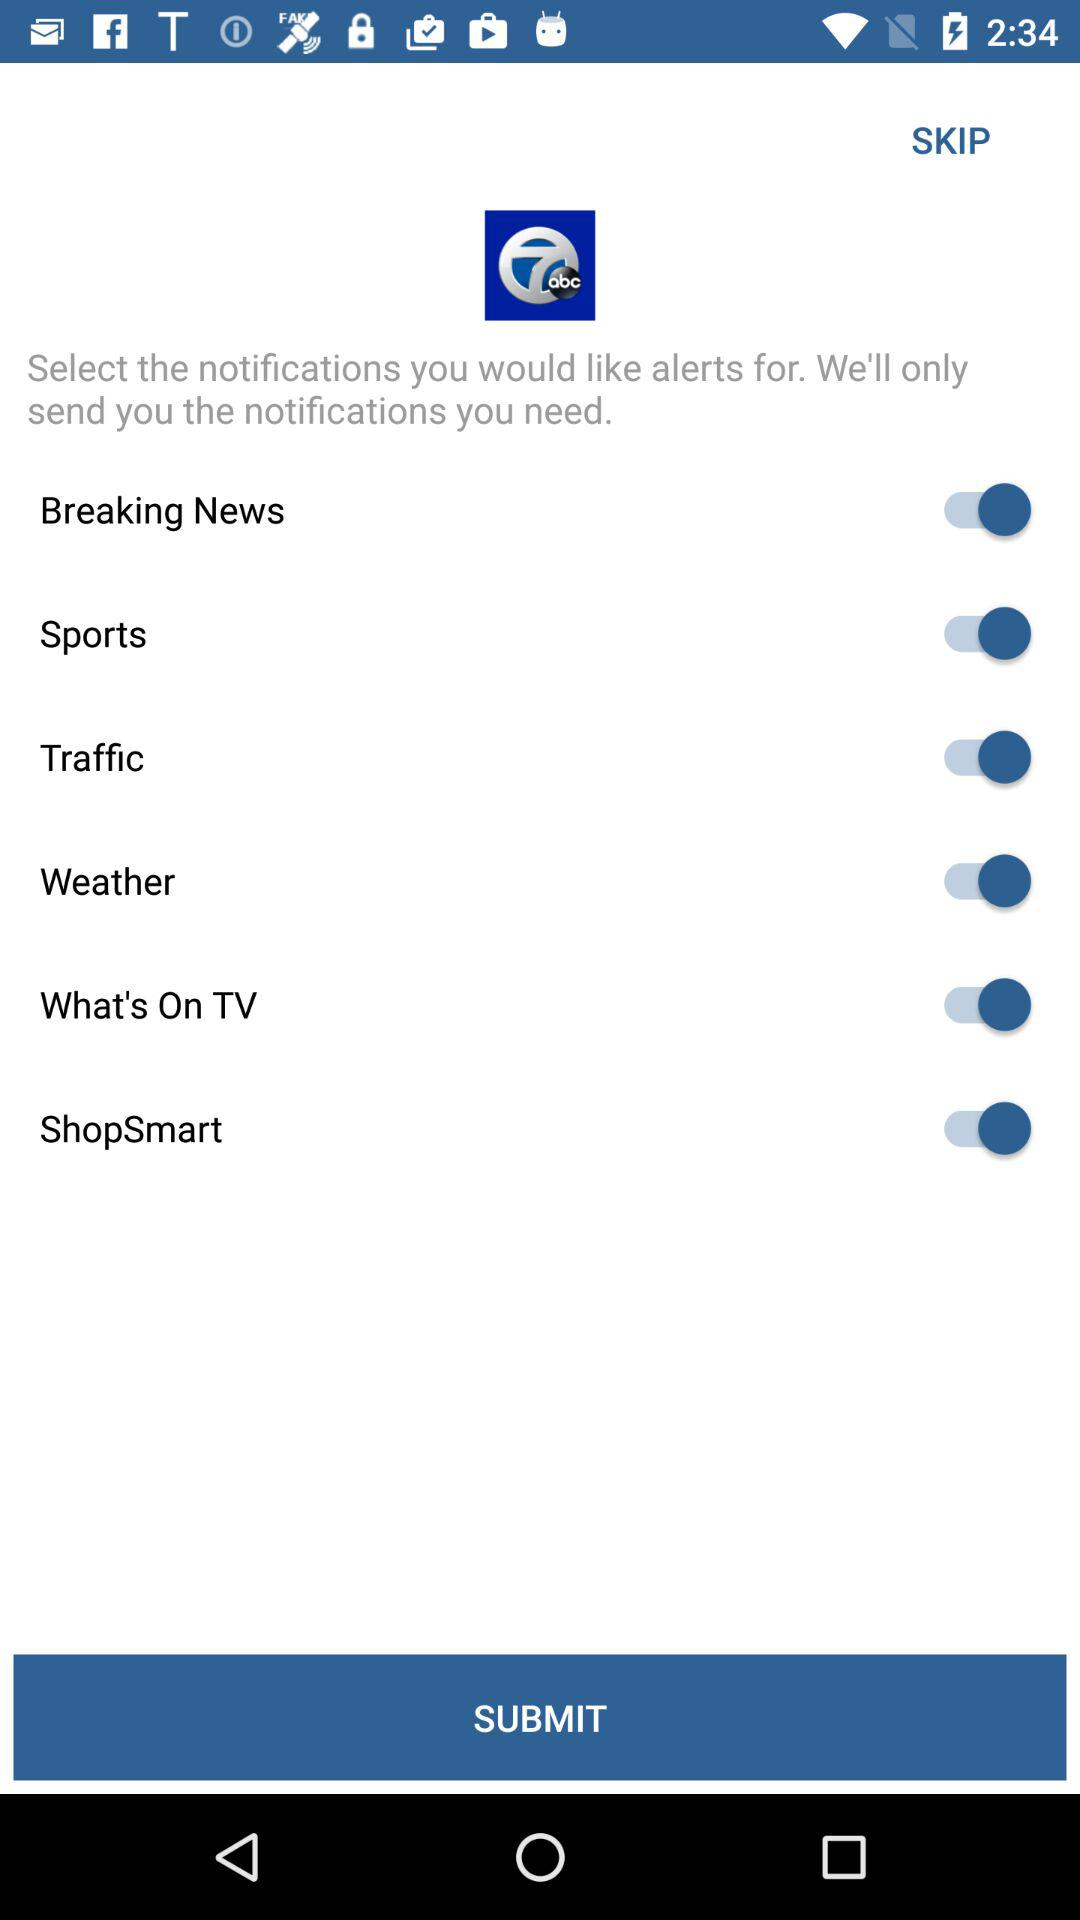What is the status of traffic? The status is on. 